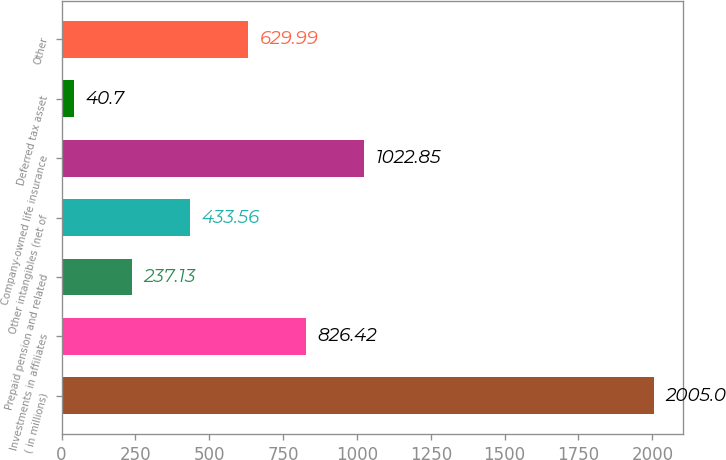<chart> <loc_0><loc_0><loc_500><loc_500><bar_chart><fcel>( in millions)<fcel>Investments in affiliates<fcel>Prepaid pension and related<fcel>Other intangibles (net of<fcel>Company-owned life insurance<fcel>Deferred tax asset<fcel>Other<nl><fcel>2005<fcel>826.42<fcel>237.13<fcel>433.56<fcel>1022.85<fcel>40.7<fcel>629.99<nl></chart> 